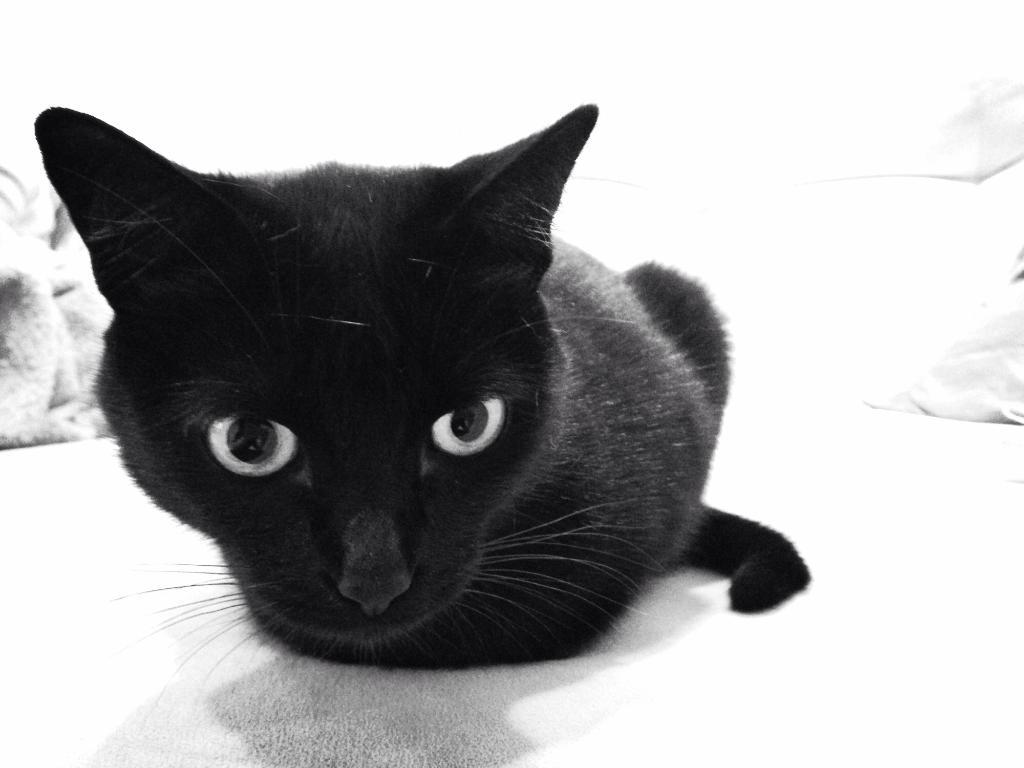What type of animal is in the image? There is a black cat in the image. What is the cat sitting on? The cat is sitting on a white cloth. What is the cat doing in the image? The cat is looking at someone. What year is the cat celebrating in the image? There is no indication of a specific year in the image, as it features a cat sitting on a white cloth and looking at someone. 